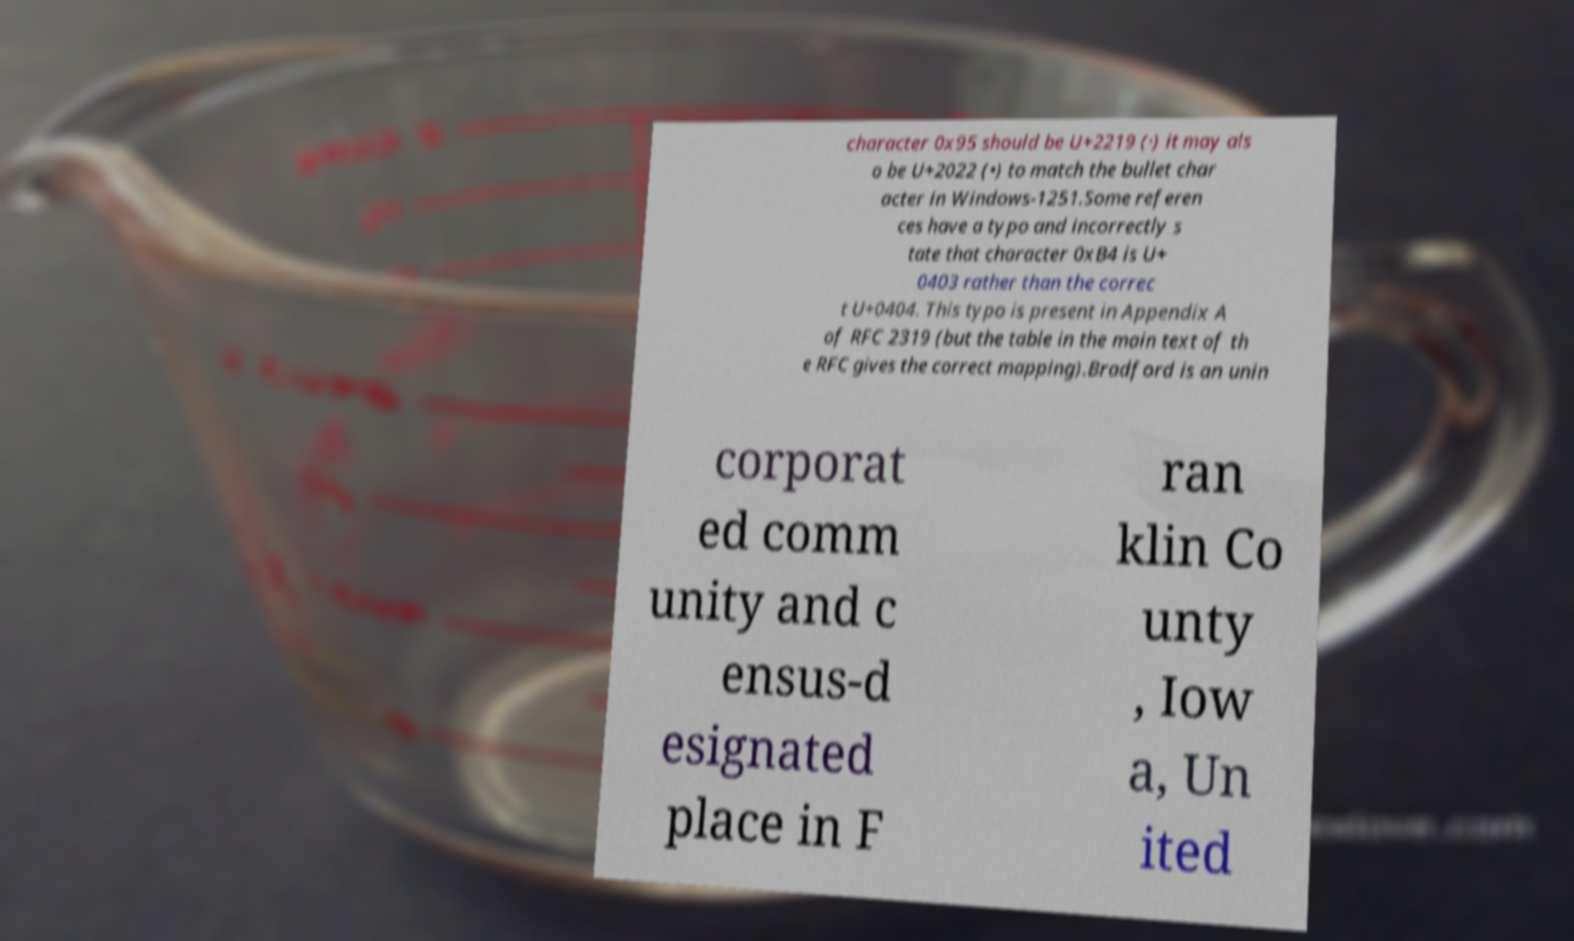Can you accurately transcribe the text from the provided image for me? character 0x95 should be U+2219 (∙) it may als o be U+2022 (•) to match the bullet char acter in Windows-1251.Some referen ces have a typo and incorrectly s tate that character 0xB4 is U+ 0403 rather than the correc t U+0404. This typo is present in Appendix A of RFC 2319 (but the table in the main text of th e RFC gives the correct mapping).Bradford is an unin corporat ed comm unity and c ensus-d esignated place in F ran klin Co unty , Iow a, Un ited 